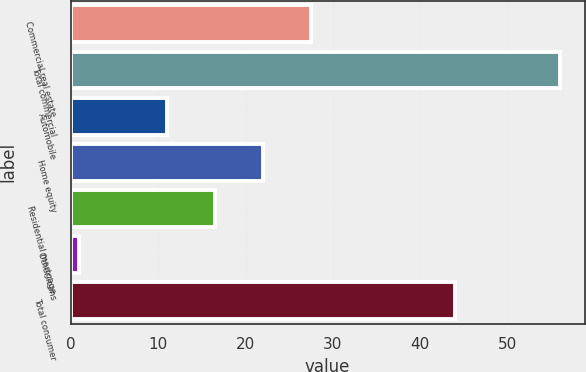<chart> <loc_0><loc_0><loc_500><loc_500><bar_chart><fcel>Commercial real estate<fcel>Total commercial<fcel>Automobile<fcel>Home equity<fcel>Residential mortgage<fcel>Other loans<fcel>Total consumer<nl><fcel>27.5<fcel>56<fcel>11<fcel>22<fcel>16.5<fcel>1<fcel>44<nl></chart> 